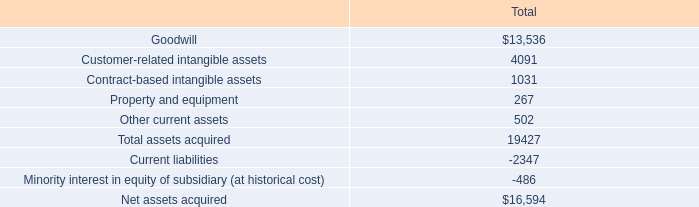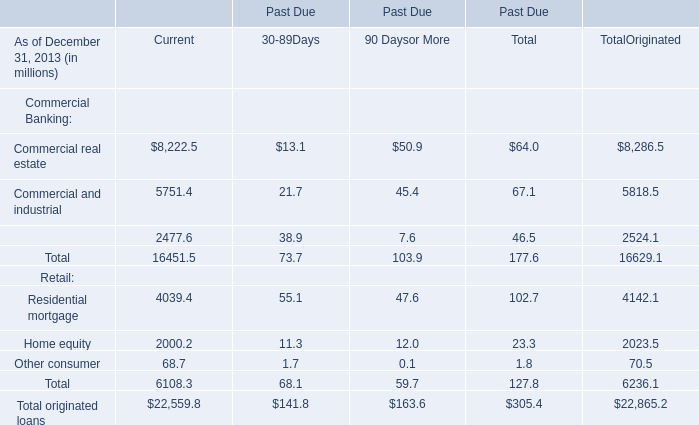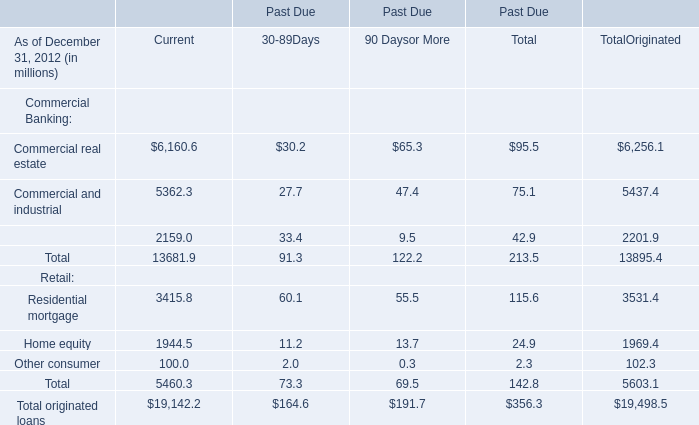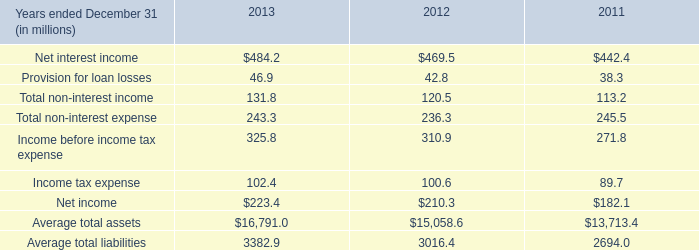what is the average yearly amortization expense related to contract-based intangible assets , ( in thousands ) ? 
Computations: (1031 / 10)
Answer: 103.1. 